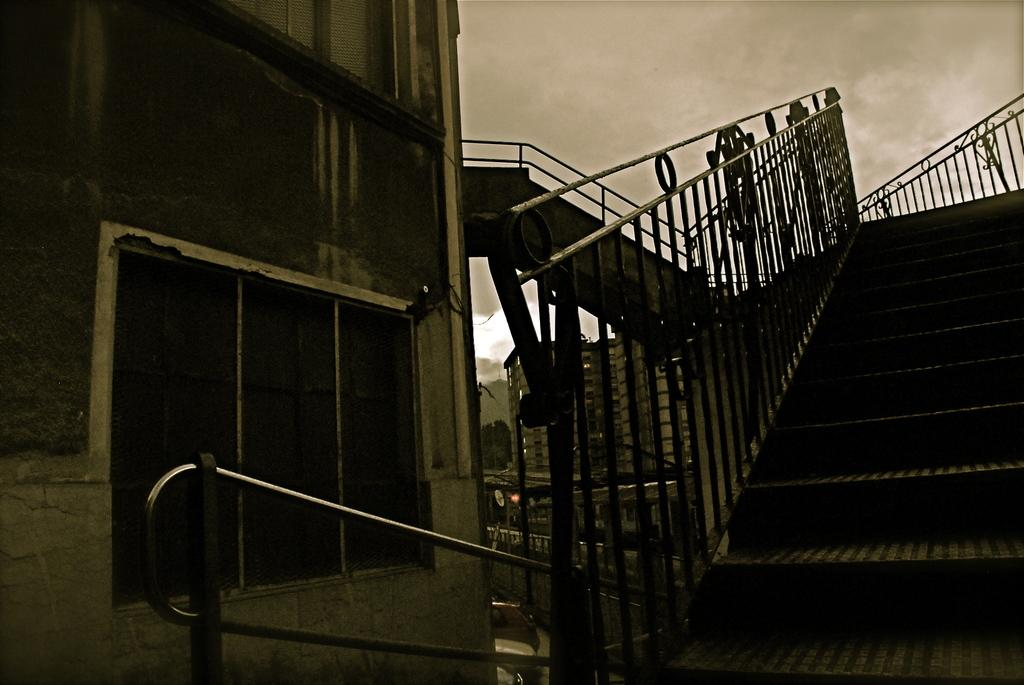What can be seen in the bottom right side of the image? There are steps in the bottom right side of the image. What type of structure is present in the image is used for enclosing or separating areas? There is fencing in the image. What is located on the left side of the image? There is a building on the left side of the image. What is visible at the top of the image? Clouds and the sky are visible at the top of the image. How many crates are stacked next to the building in the image? There are no crates present in the image. What is the scarecrow's role in the image? There is no scarecrow present in the image. 